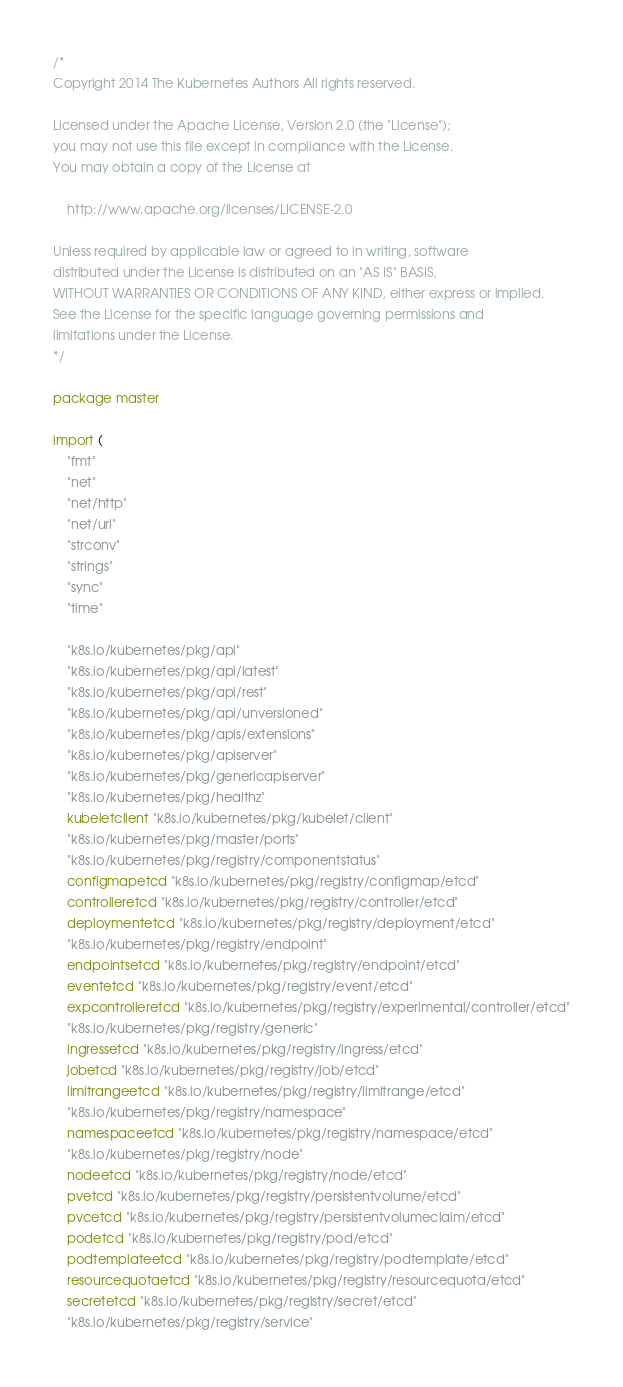<code> <loc_0><loc_0><loc_500><loc_500><_Go_>/*
Copyright 2014 The Kubernetes Authors All rights reserved.

Licensed under the Apache License, Version 2.0 (the "License");
you may not use this file except in compliance with the License.
You may obtain a copy of the License at

    http://www.apache.org/licenses/LICENSE-2.0

Unless required by applicable law or agreed to in writing, software
distributed under the License is distributed on an "AS IS" BASIS,
WITHOUT WARRANTIES OR CONDITIONS OF ANY KIND, either express or implied.
See the License for the specific language governing permissions and
limitations under the License.
*/

package master

import (
	"fmt"
	"net"
	"net/http"
	"net/url"
	"strconv"
	"strings"
	"sync"
	"time"

	"k8s.io/kubernetes/pkg/api"
	"k8s.io/kubernetes/pkg/api/latest"
	"k8s.io/kubernetes/pkg/api/rest"
	"k8s.io/kubernetes/pkg/api/unversioned"
	"k8s.io/kubernetes/pkg/apis/extensions"
	"k8s.io/kubernetes/pkg/apiserver"
	"k8s.io/kubernetes/pkg/genericapiserver"
	"k8s.io/kubernetes/pkg/healthz"
	kubeletclient "k8s.io/kubernetes/pkg/kubelet/client"
	"k8s.io/kubernetes/pkg/master/ports"
	"k8s.io/kubernetes/pkg/registry/componentstatus"
	configmapetcd "k8s.io/kubernetes/pkg/registry/configmap/etcd"
	controlleretcd "k8s.io/kubernetes/pkg/registry/controller/etcd"
	deploymentetcd "k8s.io/kubernetes/pkg/registry/deployment/etcd"
	"k8s.io/kubernetes/pkg/registry/endpoint"
	endpointsetcd "k8s.io/kubernetes/pkg/registry/endpoint/etcd"
	eventetcd "k8s.io/kubernetes/pkg/registry/event/etcd"
	expcontrolleretcd "k8s.io/kubernetes/pkg/registry/experimental/controller/etcd"
	"k8s.io/kubernetes/pkg/registry/generic"
	ingressetcd "k8s.io/kubernetes/pkg/registry/ingress/etcd"
	jobetcd "k8s.io/kubernetes/pkg/registry/job/etcd"
	limitrangeetcd "k8s.io/kubernetes/pkg/registry/limitrange/etcd"
	"k8s.io/kubernetes/pkg/registry/namespace"
	namespaceetcd "k8s.io/kubernetes/pkg/registry/namespace/etcd"
	"k8s.io/kubernetes/pkg/registry/node"
	nodeetcd "k8s.io/kubernetes/pkg/registry/node/etcd"
	pvetcd "k8s.io/kubernetes/pkg/registry/persistentvolume/etcd"
	pvcetcd "k8s.io/kubernetes/pkg/registry/persistentvolumeclaim/etcd"
	podetcd "k8s.io/kubernetes/pkg/registry/pod/etcd"
	podtemplateetcd "k8s.io/kubernetes/pkg/registry/podtemplate/etcd"
	resourcequotaetcd "k8s.io/kubernetes/pkg/registry/resourcequota/etcd"
	secretetcd "k8s.io/kubernetes/pkg/registry/secret/etcd"
	"k8s.io/kubernetes/pkg/registry/service"</code> 